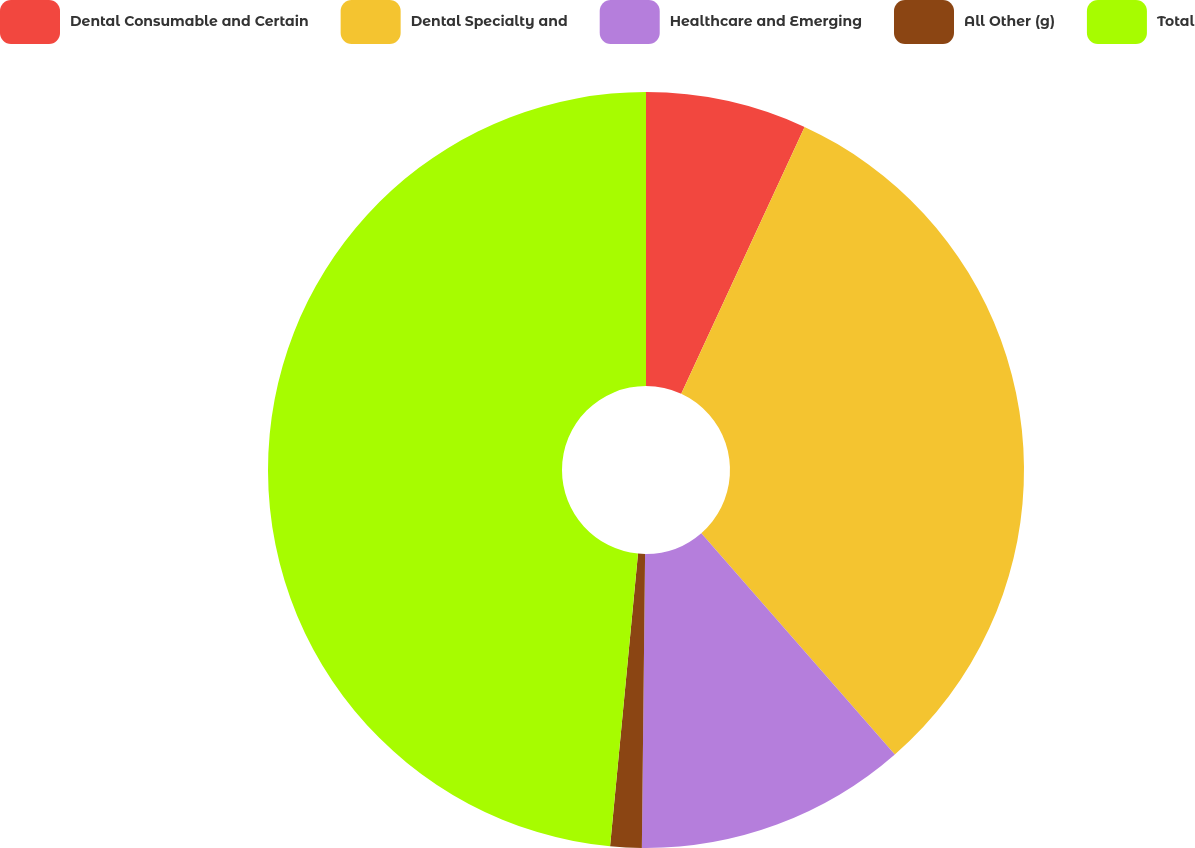Convert chart. <chart><loc_0><loc_0><loc_500><loc_500><pie_chart><fcel>Dental Consumable and Certain<fcel>Dental Specialty and<fcel>Healthcare and Emerging<fcel>All Other (g)<fcel>Total<nl><fcel>6.89%<fcel>31.67%<fcel>11.61%<fcel>1.34%<fcel>48.48%<nl></chart> 